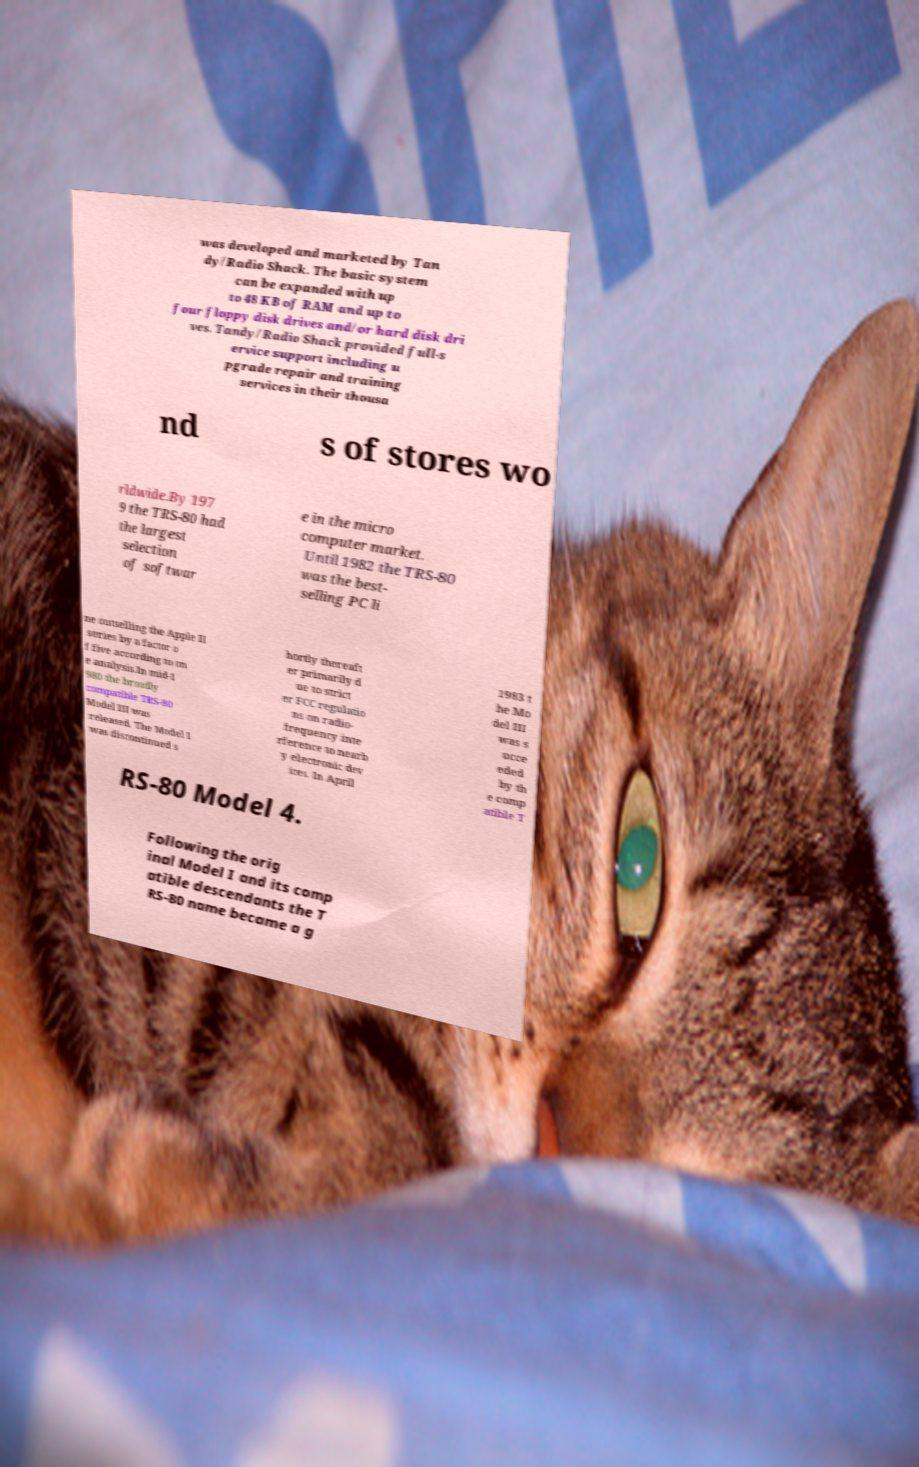For documentation purposes, I need the text within this image transcribed. Could you provide that? was developed and marketed by Tan dy/Radio Shack. The basic system can be expanded with up to 48 KB of RAM and up to four floppy disk drives and/or hard disk dri ves. Tandy/Radio Shack provided full-s ervice support including u pgrade repair and training services in their thousa nd s of stores wo rldwide.By 197 9 the TRS-80 had the largest selection of softwar e in the micro computer market. Until 1982 the TRS-80 was the best- selling PC li ne outselling the Apple II series by a factor o f five according to on e analysis.In mid-1 980 the broadly compatible TRS-80 Model III was released. The Model I was discontinued s hortly thereaft er primarily d ue to strict er FCC regulatio ns on radio- frequency inte rference to nearb y electronic dev ices. In April 1983 t he Mo del III was s ucce eded by th e comp atible T RS-80 Model 4. Following the orig inal Model I and its comp atible descendants the T RS-80 name became a g 